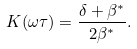<formula> <loc_0><loc_0><loc_500><loc_500>K ( \omega \tau ) = \frac { \delta + \beta ^ { * } } { 2 \beta ^ { * } } .</formula> 